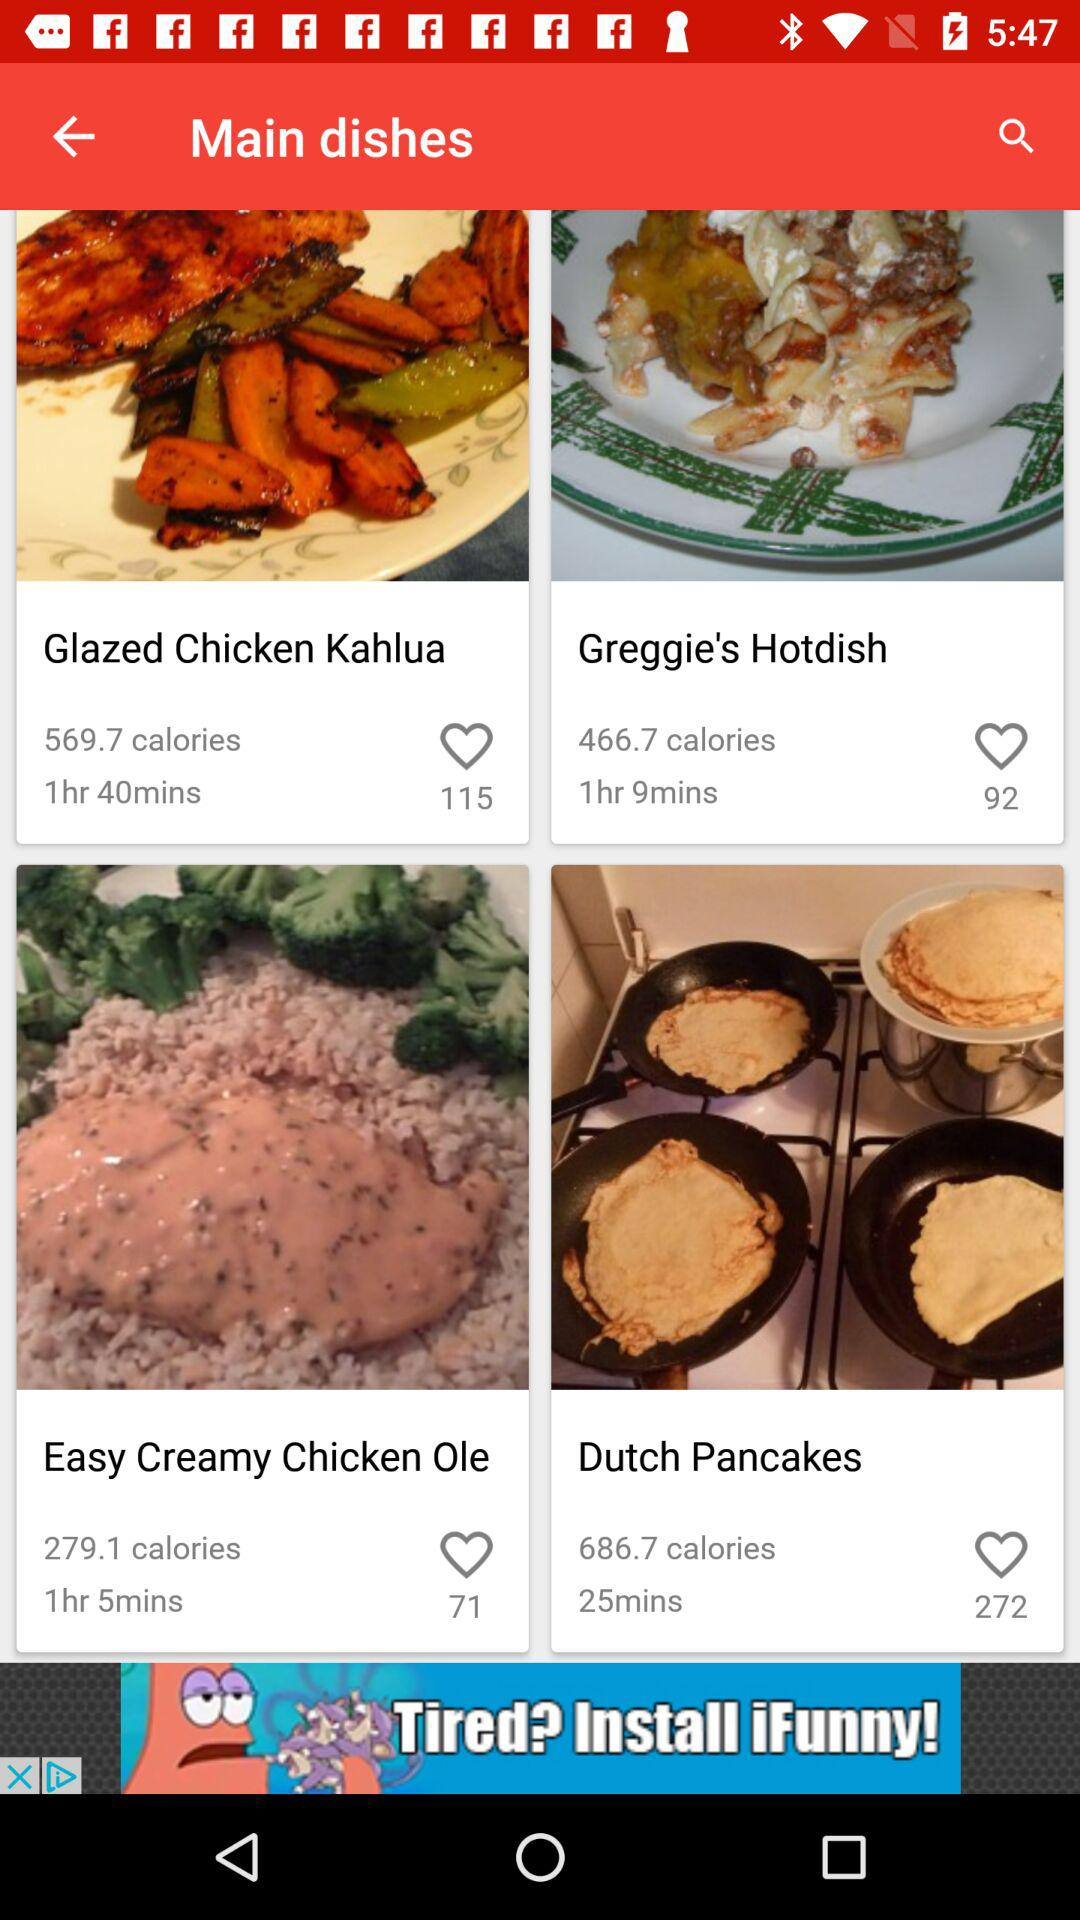How many people like "Dutch Pancakes"? The number of people who like "Dutch Pancakes" is 272. 